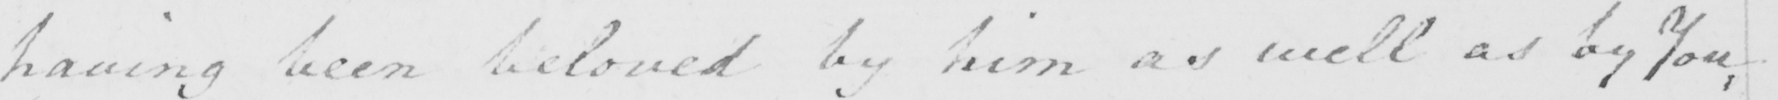What is written in this line of handwriting? having been beloved by him as well as by You , 